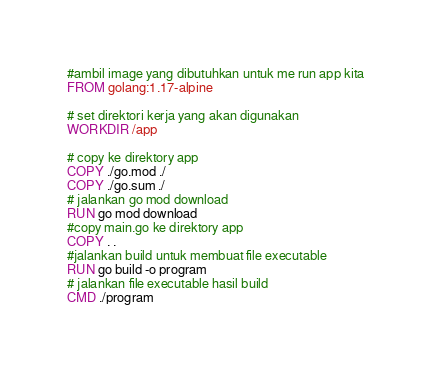<code> <loc_0><loc_0><loc_500><loc_500><_Dockerfile_>#ambil image yang dibutuhkan untuk me run app kita
FROM golang:1.17-alpine

# set direktori kerja yang akan digunakan
WORKDIR /app

# copy ke direktory app
COPY ./go.mod ./
COPY ./go.sum ./
# jalankan go mod download
RUN go mod download
#copy main.go ke direktory app
COPY . .
#jalankan build untuk membuat file executable
RUN go build -o program
# jalankan file executable hasil build
CMD ./program</code> 